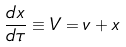<formula> <loc_0><loc_0><loc_500><loc_500>\frac { d x } { d \tau } \equiv V = v + x</formula> 